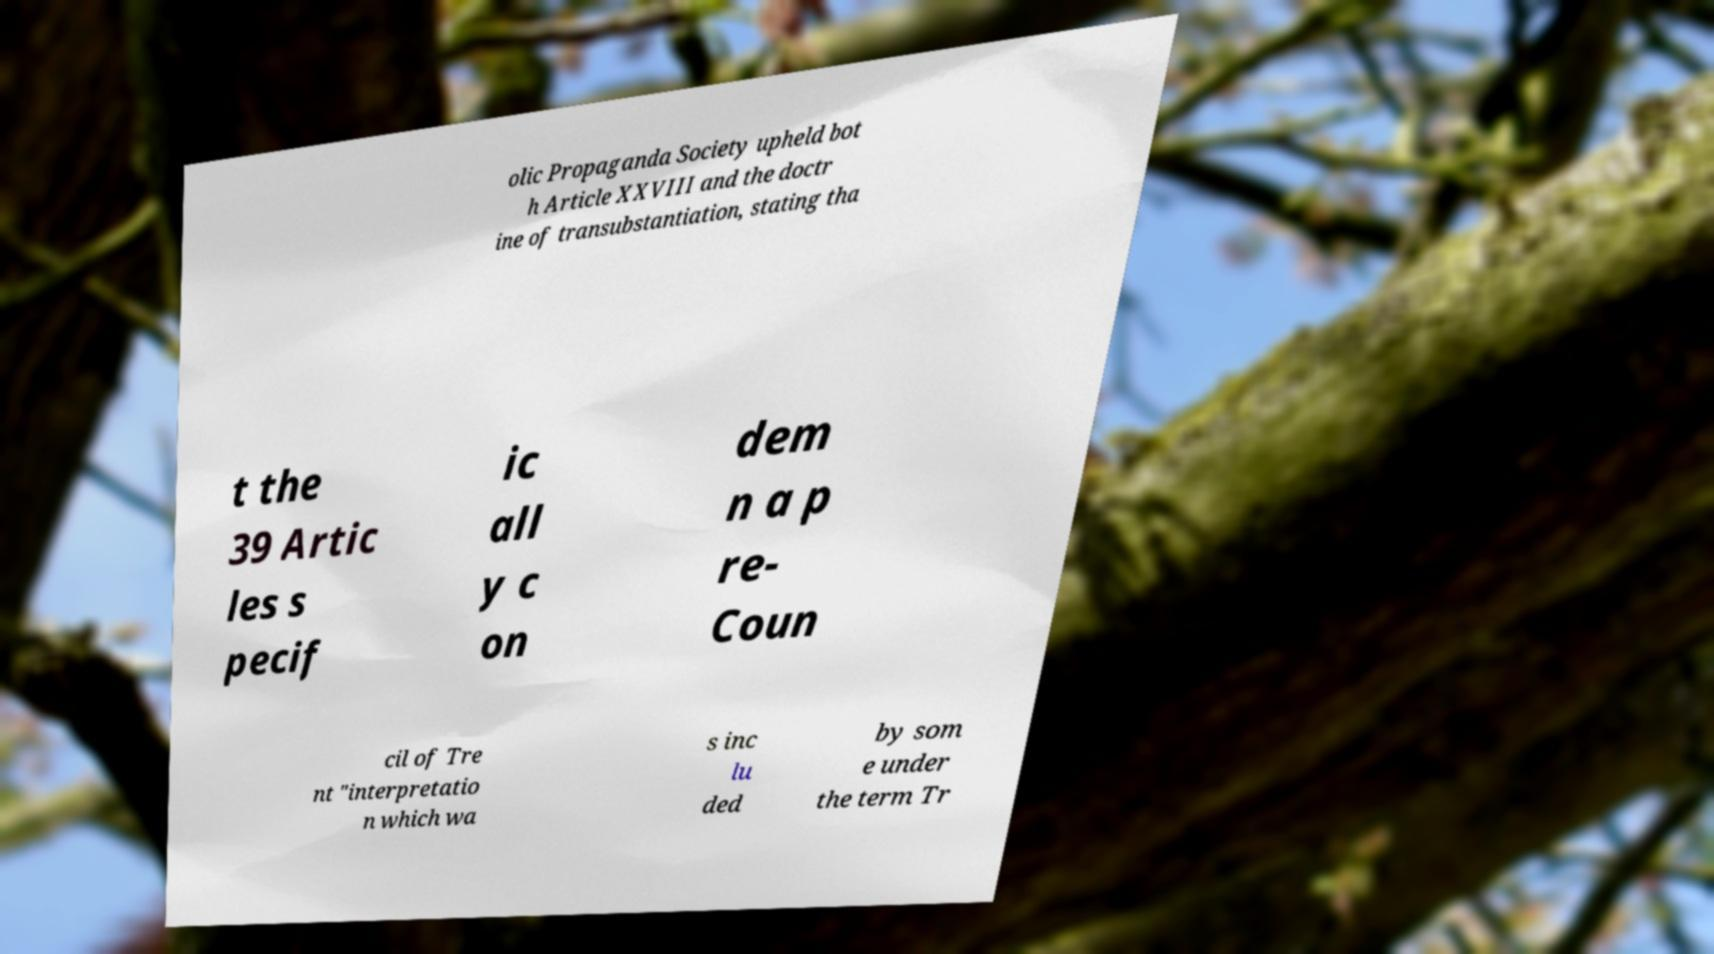For documentation purposes, I need the text within this image transcribed. Could you provide that? olic Propaganda Society upheld bot h Article XXVIII and the doctr ine of transubstantiation, stating tha t the 39 Artic les s pecif ic all y c on dem n a p re- Coun cil of Tre nt "interpretatio n which wa s inc lu ded by som e under the term Tr 